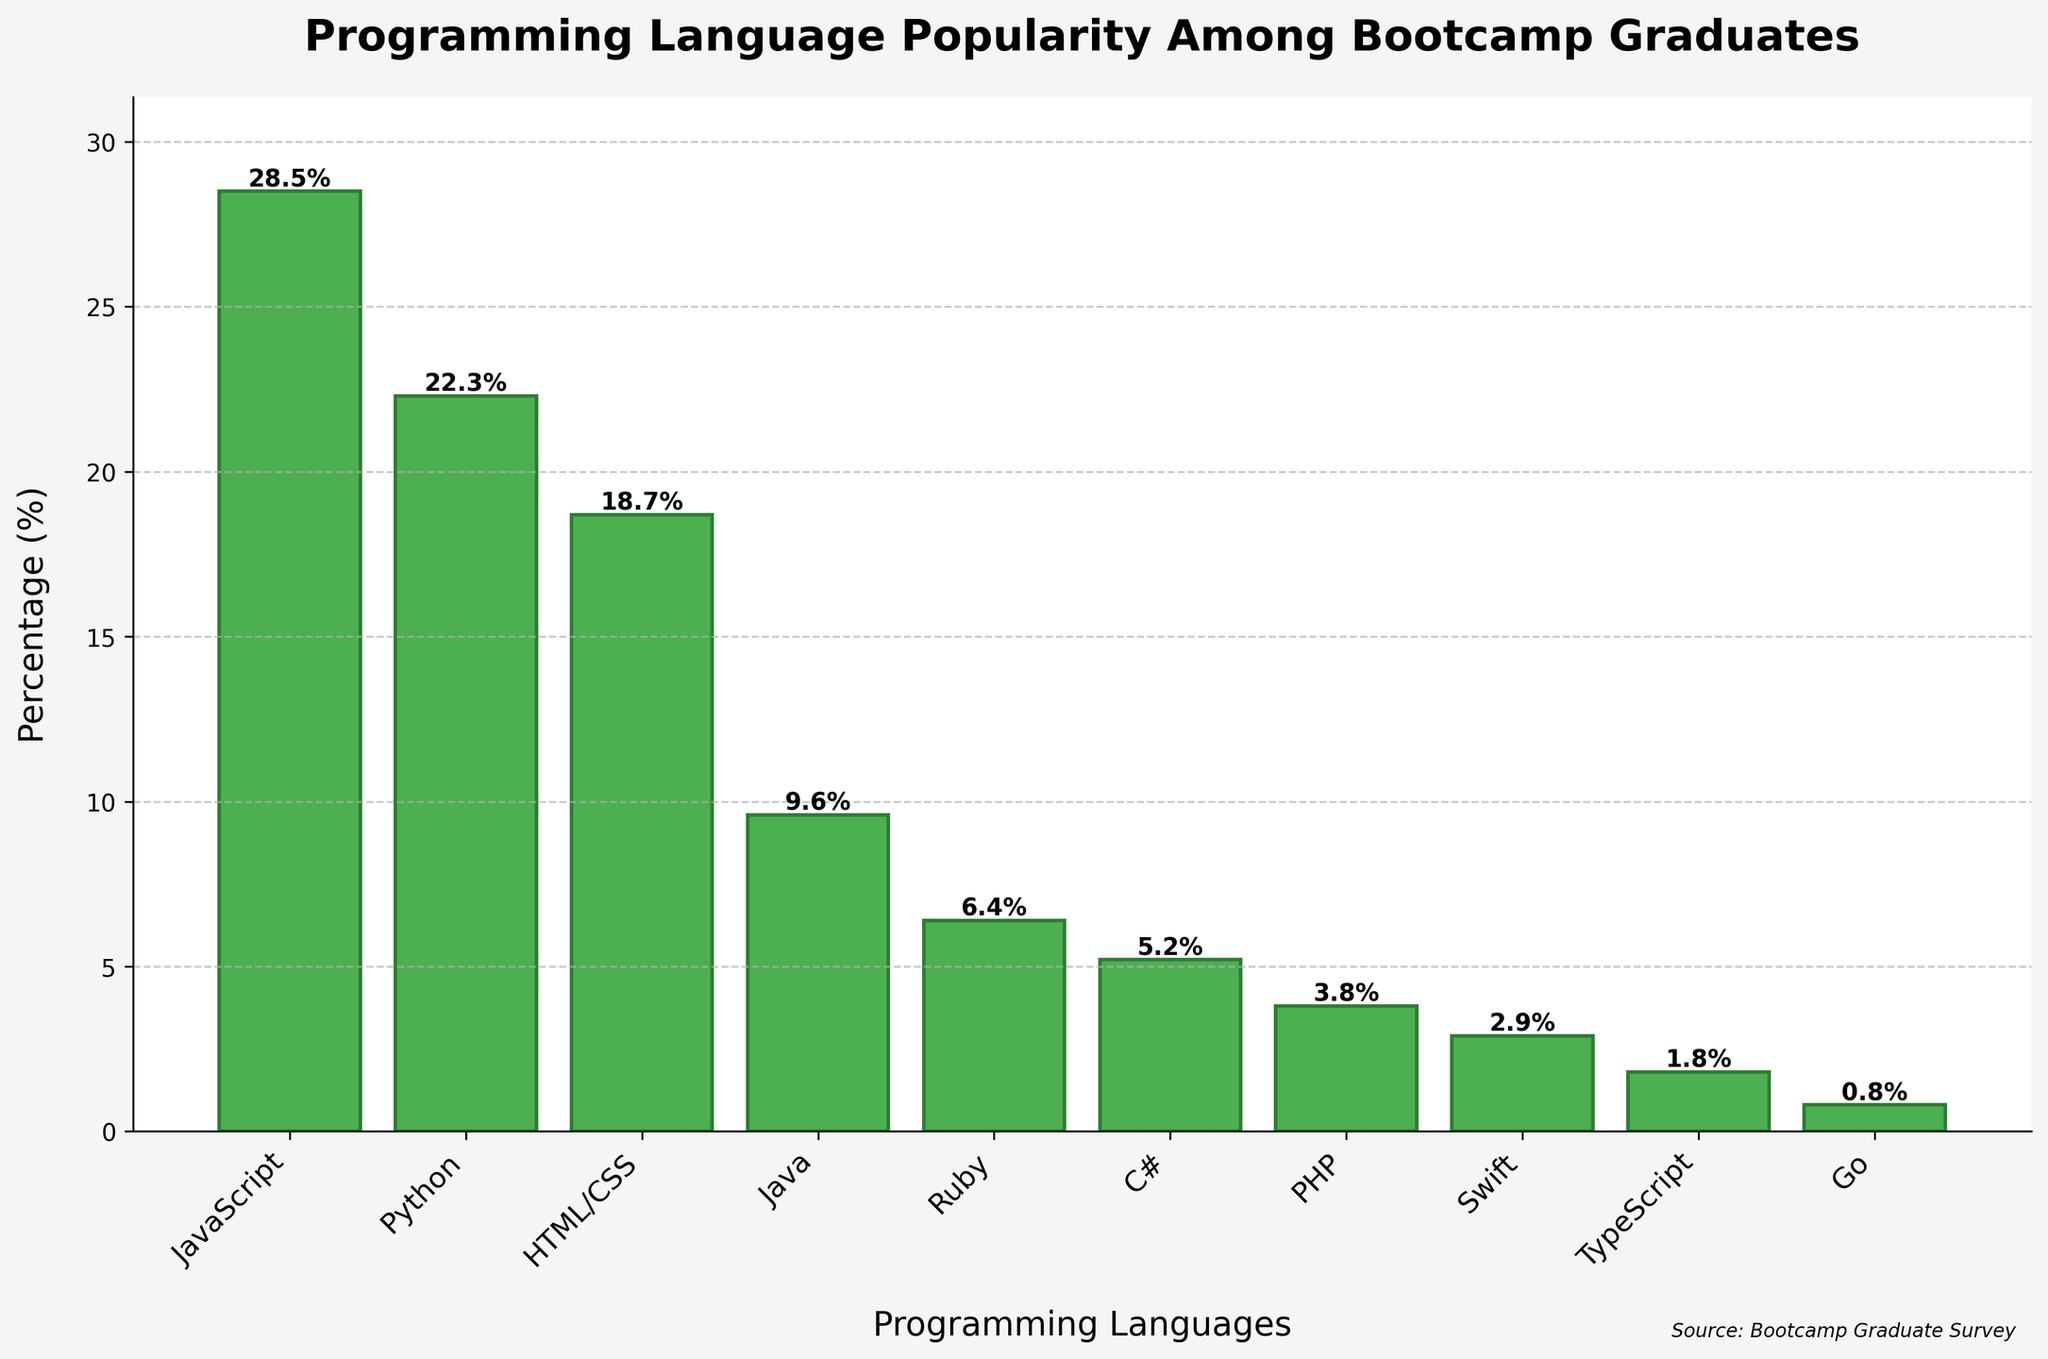Which programming language is the most popular among bootcamp graduates? The bar representing JavaScript has the highest value at 28.5%. This is evident from the height of the JavaScript bar compared to others.
Answer: JavaScript What is the combined percentage of bootcamp graduates who prefer Python and JavaScript? The percentage for Python is 22.3% and for JavaScript is 28.5%. Adding these percentages together gives 22.3% + 28.5% = 50.8%.
Answer: 50.8% How much more popular is HTML/CSS compared to PHP? HTML/CSS has a percentage of 18.7%, while PHP has 3.8%. Subtract PHP's percentage from HTML/CSS's percentage to find the difference: 18.7% - 3.8% = 14.9%.
Answer: 14.9% Which language is less popular, Swift or Go, and by how much? The bar for Swift is higher than that for Go. Swift is at 2.9%, and Go is at 0.8%. The difference is 2.9% - 0.8% = 2.1%.
Answer: Go, by 2.1% Is Python more popular than Java and by what percentage? Python has a percentage of 22.3%, and Java has 9.6%. Subtract Java's percentage from Python's to find the difference: 22.3% - 9.6% = 12.7%.
Answer: Yes, by 12.7% What is the average popularity percentage of Ruby, C#, and PHP together? The percentages for Ruby, C# and PHP are 6.4%, 5.2%, and 3.8% respectively. Sum them up: 6.4 + 5.2 + 3.8 = 15.4. The average is 15.4/3 = 5.13%.
Answer: 5.13% What percentage of the graduates favor languages other than JavaScript, Python, and HTML/CSS? The sums of JavaScript (28.5%), Python (22.3%), and HTML/CSS (18.7%) give 28.5 + 22.3 + 18.7 = 69.5%. Subtract this from 100% to find the percentage for other languages: 100 - 69.5 = 30.5%.
Answer: 30.5% What language is the least popular, and what is its percentage? The smallest bar in the chart corresponds to Go, with a percentage value of 0.8%.
Answer: Go, 0.8% 